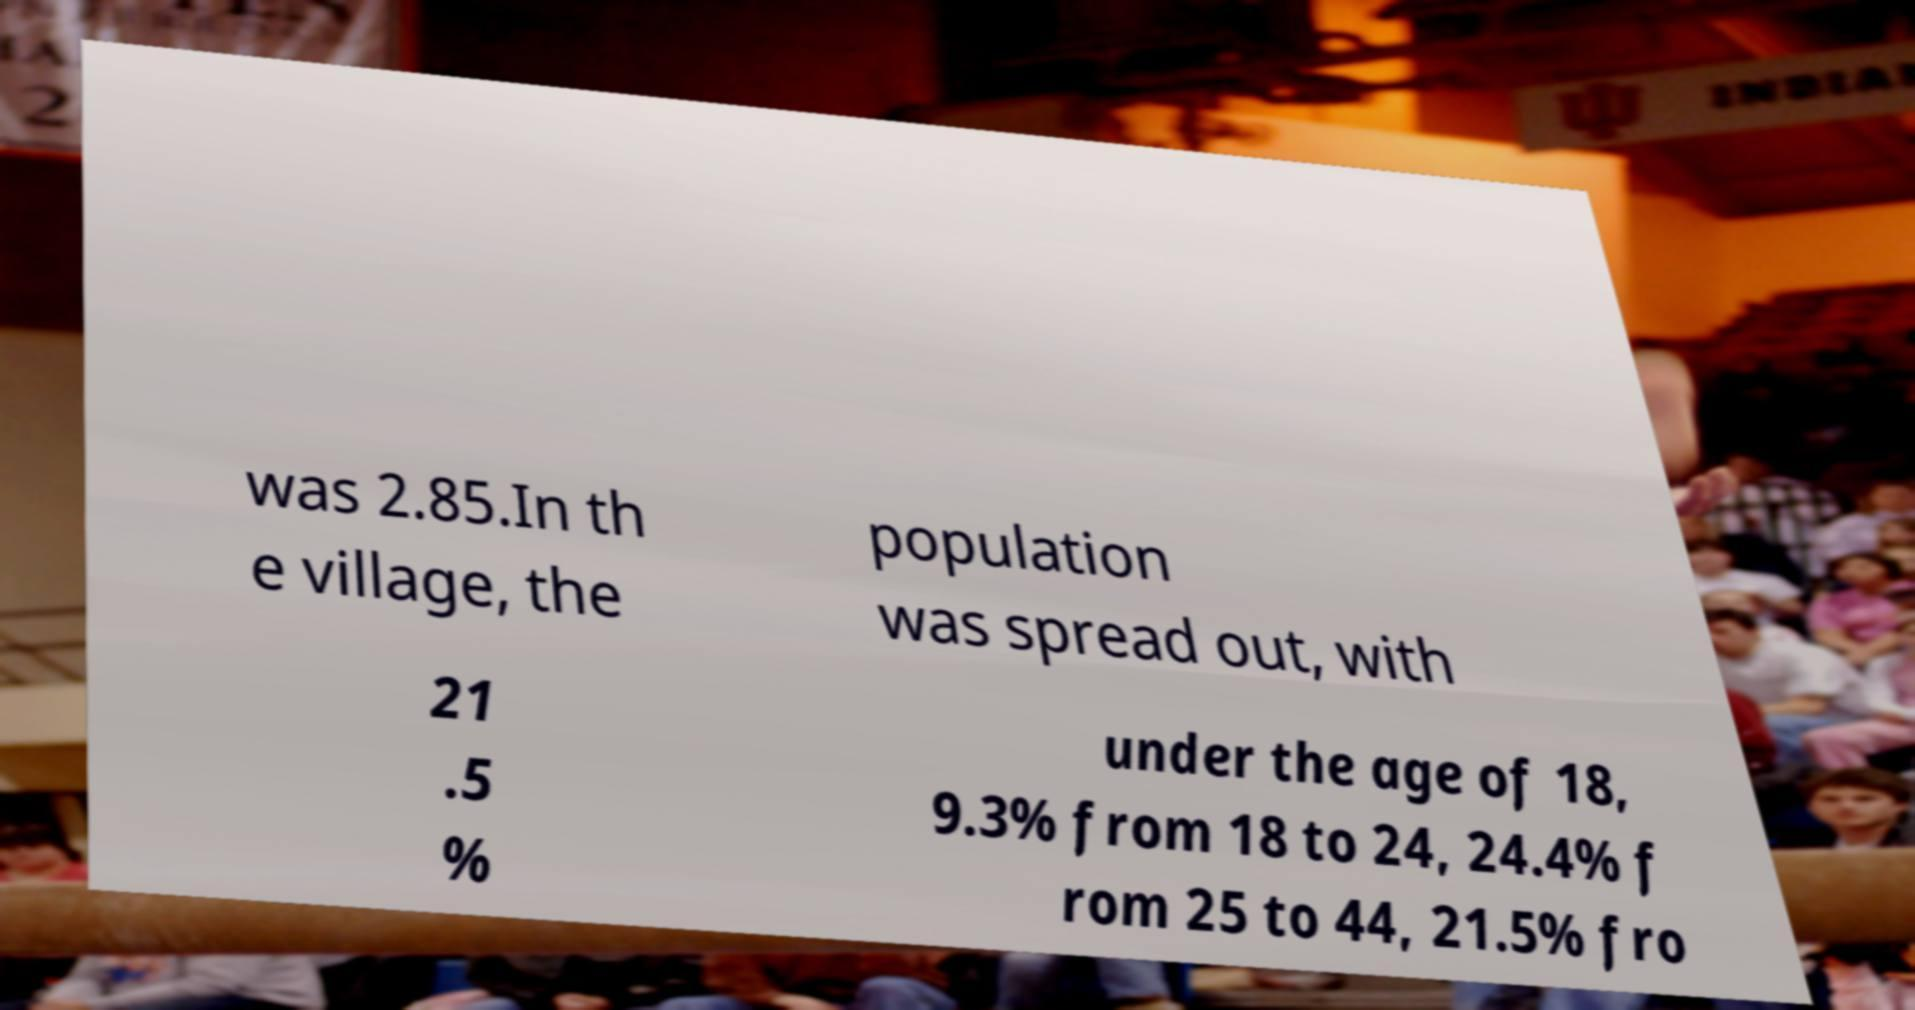I need the written content from this picture converted into text. Can you do that? was 2.85.In th e village, the population was spread out, with 21 .5 % under the age of 18, 9.3% from 18 to 24, 24.4% f rom 25 to 44, 21.5% fro 